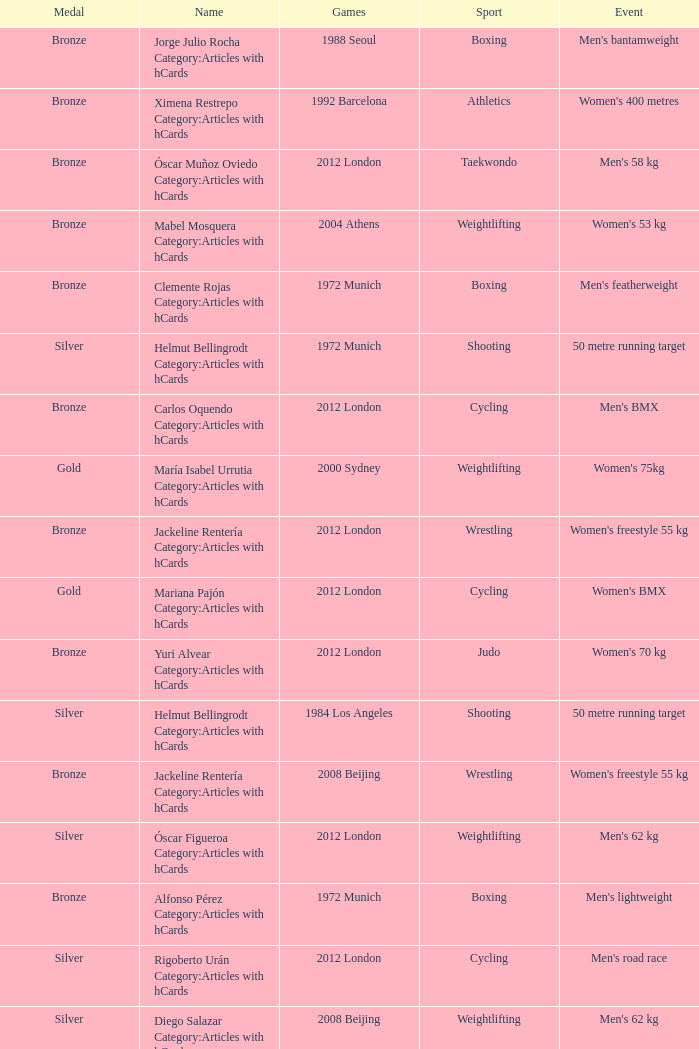What wrestling event was participated in during the 2008 Beijing games? Women's freestyle 55 kg. 